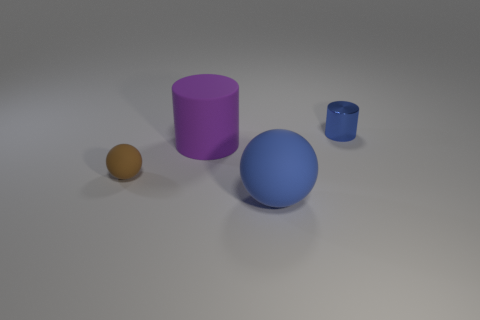What number of other big objects are the same color as the metallic thing?
Offer a terse response. 1. What number of other objects are there of the same size as the blue shiny object?
Ensure brevity in your answer.  1. How many blue objects are both behind the purple cylinder and to the left of the small blue cylinder?
Offer a terse response. 0. Is the material of the ball that is in front of the brown thing the same as the blue cylinder?
Your answer should be very brief. No. The rubber thing right of the big object that is on the left side of the blue object that is left of the small cylinder is what shape?
Your answer should be compact. Sphere. Is the number of tiny matte spheres on the right side of the large rubber sphere the same as the number of blue objects that are on the right side of the small blue metal cylinder?
Keep it short and to the point. Yes. What is the color of the other object that is the same size as the brown matte object?
Ensure brevity in your answer.  Blue. What number of large things are purple matte blocks or spheres?
Provide a succinct answer. 1. What material is the thing that is right of the big purple matte object and behind the big blue ball?
Your answer should be compact. Metal. Do the big matte object that is behind the small brown matte object and the blue object that is in front of the purple rubber thing have the same shape?
Make the answer very short. No. 